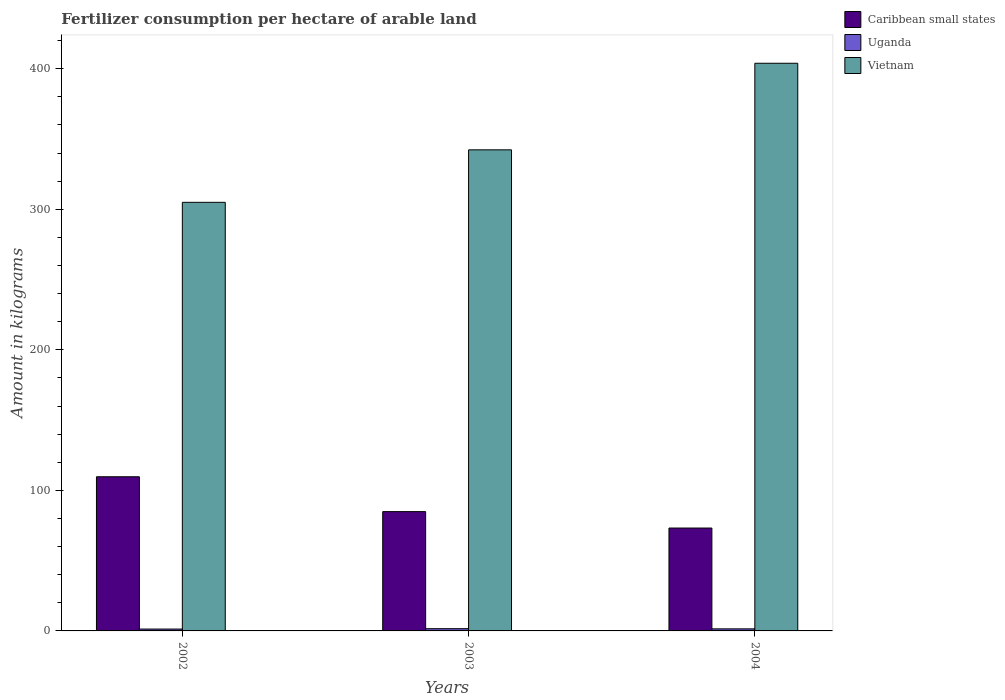How many different coloured bars are there?
Provide a short and direct response. 3. How many groups of bars are there?
Keep it short and to the point. 3. Are the number of bars per tick equal to the number of legend labels?
Offer a very short reply. Yes. Are the number of bars on each tick of the X-axis equal?
Give a very brief answer. Yes. How many bars are there on the 2nd tick from the left?
Offer a very short reply. 3. How many bars are there on the 2nd tick from the right?
Make the answer very short. 3. What is the label of the 1st group of bars from the left?
Offer a terse response. 2002. In how many cases, is the number of bars for a given year not equal to the number of legend labels?
Give a very brief answer. 0. What is the amount of fertilizer consumption in Uganda in 2004?
Your answer should be very brief. 1.47. Across all years, what is the maximum amount of fertilizer consumption in Vietnam?
Your response must be concise. 403.91. Across all years, what is the minimum amount of fertilizer consumption in Vietnam?
Ensure brevity in your answer.  304.96. What is the total amount of fertilizer consumption in Uganda in the graph?
Give a very brief answer. 4.4. What is the difference between the amount of fertilizer consumption in Uganda in 2003 and that in 2004?
Provide a succinct answer. 0.12. What is the difference between the amount of fertilizer consumption in Uganda in 2003 and the amount of fertilizer consumption in Vietnam in 2004?
Offer a terse response. -402.31. What is the average amount of fertilizer consumption in Caribbean small states per year?
Provide a short and direct response. 89.26. In the year 2004, what is the difference between the amount of fertilizer consumption in Uganda and amount of fertilizer consumption in Caribbean small states?
Your answer should be compact. -71.74. In how many years, is the amount of fertilizer consumption in Uganda greater than 240 kg?
Your response must be concise. 0. What is the ratio of the amount of fertilizer consumption in Uganda in 2003 to that in 2004?
Give a very brief answer. 1.08. Is the amount of fertilizer consumption in Uganda in 2002 less than that in 2004?
Ensure brevity in your answer.  Yes. Is the difference between the amount of fertilizer consumption in Uganda in 2002 and 2004 greater than the difference between the amount of fertilizer consumption in Caribbean small states in 2002 and 2004?
Offer a very short reply. No. What is the difference between the highest and the second highest amount of fertilizer consumption in Uganda?
Provide a short and direct response. 0.12. What is the difference between the highest and the lowest amount of fertilizer consumption in Caribbean small states?
Provide a succinct answer. 36.48. In how many years, is the amount of fertilizer consumption in Vietnam greater than the average amount of fertilizer consumption in Vietnam taken over all years?
Provide a short and direct response. 1. What does the 3rd bar from the left in 2004 represents?
Ensure brevity in your answer.  Vietnam. What does the 1st bar from the right in 2003 represents?
Your response must be concise. Vietnam. Is it the case that in every year, the sum of the amount of fertilizer consumption in Vietnam and amount of fertilizer consumption in Uganda is greater than the amount of fertilizer consumption in Caribbean small states?
Your answer should be very brief. Yes. How many bars are there?
Provide a succinct answer. 9. Are the values on the major ticks of Y-axis written in scientific E-notation?
Keep it short and to the point. No. What is the title of the graph?
Your answer should be compact. Fertilizer consumption per hectare of arable land. Does "Bolivia" appear as one of the legend labels in the graph?
Make the answer very short. No. What is the label or title of the Y-axis?
Offer a very short reply. Amount in kilograms. What is the Amount in kilograms of Caribbean small states in 2002?
Offer a terse response. 109.69. What is the Amount in kilograms in Uganda in 2002?
Your answer should be compact. 1.33. What is the Amount in kilograms in Vietnam in 2002?
Your answer should be very brief. 304.96. What is the Amount in kilograms in Caribbean small states in 2003?
Provide a succinct answer. 84.89. What is the Amount in kilograms in Uganda in 2003?
Offer a very short reply. 1.6. What is the Amount in kilograms in Vietnam in 2003?
Give a very brief answer. 342.3. What is the Amount in kilograms in Caribbean small states in 2004?
Keep it short and to the point. 73.21. What is the Amount in kilograms in Uganda in 2004?
Your answer should be very brief. 1.47. What is the Amount in kilograms in Vietnam in 2004?
Offer a terse response. 403.91. Across all years, what is the maximum Amount in kilograms of Caribbean small states?
Offer a terse response. 109.69. Across all years, what is the maximum Amount in kilograms of Uganda?
Ensure brevity in your answer.  1.6. Across all years, what is the maximum Amount in kilograms of Vietnam?
Offer a very short reply. 403.91. Across all years, what is the minimum Amount in kilograms in Caribbean small states?
Provide a succinct answer. 73.21. Across all years, what is the minimum Amount in kilograms in Uganda?
Offer a terse response. 1.33. Across all years, what is the minimum Amount in kilograms in Vietnam?
Offer a terse response. 304.96. What is the total Amount in kilograms in Caribbean small states in the graph?
Make the answer very short. 267.78. What is the total Amount in kilograms in Uganda in the graph?
Make the answer very short. 4.4. What is the total Amount in kilograms of Vietnam in the graph?
Provide a succinct answer. 1051.17. What is the difference between the Amount in kilograms in Caribbean small states in 2002 and that in 2003?
Your response must be concise. 24.8. What is the difference between the Amount in kilograms in Uganda in 2002 and that in 2003?
Your answer should be very brief. -0.26. What is the difference between the Amount in kilograms in Vietnam in 2002 and that in 2003?
Make the answer very short. -37.34. What is the difference between the Amount in kilograms in Caribbean small states in 2002 and that in 2004?
Your response must be concise. 36.48. What is the difference between the Amount in kilograms in Uganda in 2002 and that in 2004?
Offer a very short reply. -0.14. What is the difference between the Amount in kilograms of Vietnam in 2002 and that in 2004?
Your answer should be compact. -98.94. What is the difference between the Amount in kilograms of Caribbean small states in 2003 and that in 2004?
Give a very brief answer. 11.68. What is the difference between the Amount in kilograms in Uganda in 2003 and that in 2004?
Offer a very short reply. 0.12. What is the difference between the Amount in kilograms in Vietnam in 2003 and that in 2004?
Make the answer very short. -61.6. What is the difference between the Amount in kilograms of Caribbean small states in 2002 and the Amount in kilograms of Uganda in 2003?
Your response must be concise. 108.1. What is the difference between the Amount in kilograms of Caribbean small states in 2002 and the Amount in kilograms of Vietnam in 2003?
Offer a terse response. -232.61. What is the difference between the Amount in kilograms in Uganda in 2002 and the Amount in kilograms in Vietnam in 2003?
Keep it short and to the point. -340.97. What is the difference between the Amount in kilograms of Caribbean small states in 2002 and the Amount in kilograms of Uganda in 2004?
Give a very brief answer. 108.22. What is the difference between the Amount in kilograms of Caribbean small states in 2002 and the Amount in kilograms of Vietnam in 2004?
Offer a terse response. -294.22. What is the difference between the Amount in kilograms of Uganda in 2002 and the Amount in kilograms of Vietnam in 2004?
Keep it short and to the point. -402.57. What is the difference between the Amount in kilograms in Caribbean small states in 2003 and the Amount in kilograms in Uganda in 2004?
Keep it short and to the point. 83.41. What is the difference between the Amount in kilograms in Caribbean small states in 2003 and the Amount in kilograms in Vietnam in 2004?
Your answer should be very brief. -319.02. What is the difference between the Amount in kilograms of Uganda in 2003 and the Amount in kilograms of Vietnam in 2004?
Offer a very short reply. -402.31. What is the average Amount in kilograms of Caribbean small states per year?
Offer a terse response. 89.26. What is the average Amount in kilograms in Uganda per year?
Give a very brief answer. 1.47. What is the average Amount in kilograms in Vietnam per year?
Your answer should be very brief. 350.39. In the year 2002, what is the difference between the Amount in kilograms in Caribbean small states and Amount in kilograms in Uganda?
Your answer should be compact. 108.36. In the year 2002, what is the difference between the Amount in kilograms in Caribbean small states and Amount in kilograms in Vietnam?
Your response must be concise. -195.27. In the year 2002, what is the difference between the Amount in kilograms in Uganda and Amount in kilograms in Vietnam?
Offer a very short reply. -303.63. In the year 2003, what is the difference between the Amount in kilograms of Caribbean small states and Amount in kilograms of Uganda?
Provide a succinct answer. 83.29. In the year 2003, what is the difference between the Amount in kilograms in Caribbean small states and Amount in kilograms in Vietnam?
Provide a succinct answer. -257.42. In the year 2003, what is the difference between the Amount in kilograms of Uganda and Amount in kilograms of Vietnam?
Provide a short and direct response. -340.71. In the year 2004, what is the difference between the Amount in kilograms in Caribbean small states and Amount in kilograms in Uganda?
Make the answer very short. 71.74. In the year 2004, what is the difference between the Amount in kilograms of Caribbean small states and Amount in kilograms of Vietnam?
Provide a succinct answer. -330.7. In the year 2004, what is the difference between the Amount in kilograms in Uganda and Amount in kilograms in Vietnam?
Provide a short and direct response. -402.44. What is the ratio of the Amount in kilograms of Caribbean small states in 2002 to that in 2003?
Offer a very short reply. 1.29. What is the ratio of the Amount in kilograms in Uganda in 2002 to that in 2003?
Provide a short and direct response. 0.84. What is the ratio of the Amount in kilograms in Vietnam in 2002 to that in 2003?
Provide a succinct answer. 0.89. What is the ratio of the Amount in kilograms of Caribbean small states in 2002 to that in 2004?
Your answer should be compact. 1.5. What is the ratio of the Amount in kilograms in Uganda in 2002 to that in 2004?
Provide a succinct answer. 0.91. What is the ratio of the Amount in kilograms of Vietnam in 2002 to that in 2004?
Provide a succinct answer. 0.76. What is the ratio of the Amount in kilograms in Caribbean small states in 2003 to that in 2004?
Offer a very short reply. 1.16. What is the ratio of the Amount in kilograms in Uganda in 2003 to that in 2004?
Provide a short and direct response. 1.08. What is the ratio of the Amount in kilograms in Vietnam in 2003 to that in 2004?
Offer a very short reply. 0.85. What is the difference between the highest and the second highest Amount in kilograms in Caribbean small states?
Offer a very short reply. 24.8. What is the difference between the highest and the second highest Amount in kilograms of Uganda?
Make the answer very short. 0.12. What is the difference between the highest and the second highest Amount in kilograms in Vietnam?
Give a very brief answer. 61.6. What is the difference between the highest and the lowest Amount in kilograms in Caribbean small states?
Offer a terse response. 36.48. What is the difference between the highest and the lowest Amount in kilograms in Uganda?
Keep it short and to the point. 0.26. What is the difference between the highest and the lowest Amount in kilograms of Vietnam?
Make the answer very short. 98.94. 